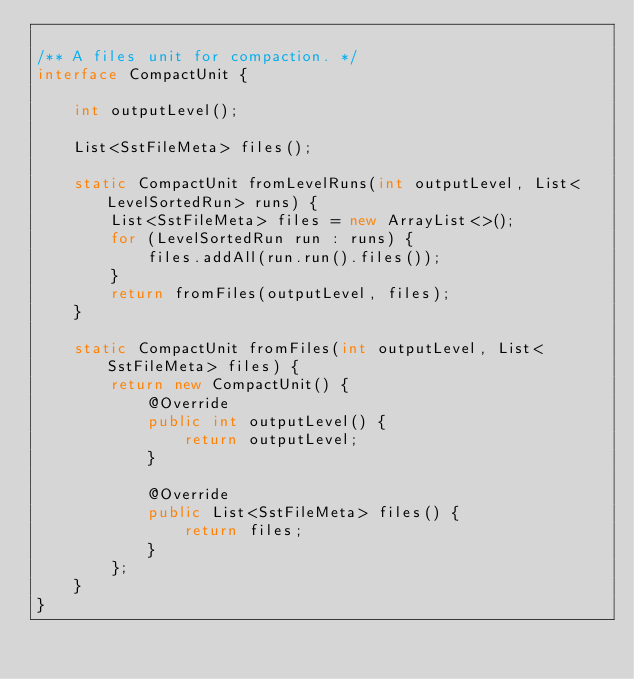Convert code to text. <code><loc_0><loc_0><loc_500><loc_500><_Java_>
/** A files unit for compaction. */
interface CompactUnit {

    int outputLevel();

    List<SstFileMeta> files();

    static CompactUnit fromLevelRuns(int outputLevel, List<LevelSortedRun> runs) {
        List<SstFileMeta> files = new ArrayList<>();
        for (LevelSortedRun run : runs) {
            files.addAll(run.run().files());
        }
        return fromFiles(outputLevel, files);
    }

    static CompactUnit fromFiles(int outputLevel, List<SstFileMeta> files) {
        return new CompactUnit() {
            @Override
            public int outputLevel() {
                return outputLevel;
            }

            @Override
            public List<SstFileMeta> files() {
                return files;
            }
        };
    }
}
</code> 